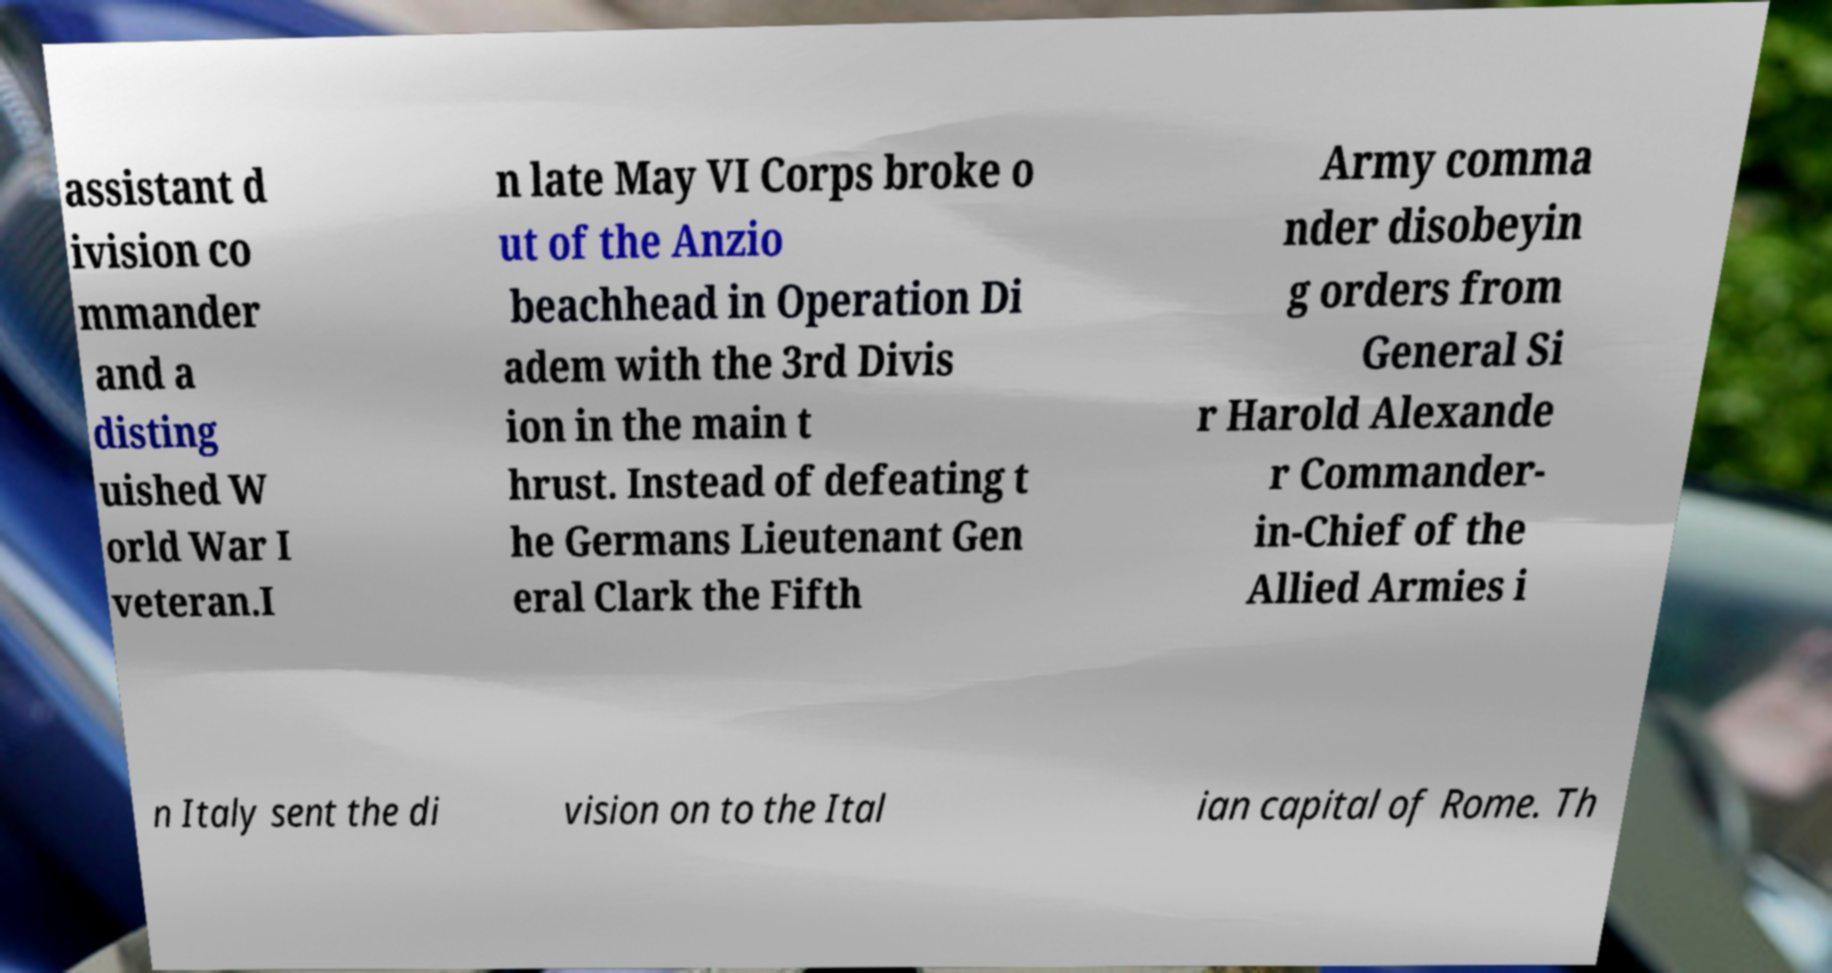There's text embedded in this image that I need extracted. Can you transcribe it verbatim? assistant d ivision co mmander and a disting uished W orld War I veteran.I n late May VI Corps broke o ut of the Anzio beachhead in Operation Di adem with the 3rd Divis ion in the main t hrust. Instead of defeating t he Germans Lieutenant Gen eral Clark the Fifth Army comma nder disobeyin g orders from General Si r Harold Alexande r Commander- in-Chief of the Allied Armies i n Italy sent the di vision on to the Ital ian capital of Rome. Th 